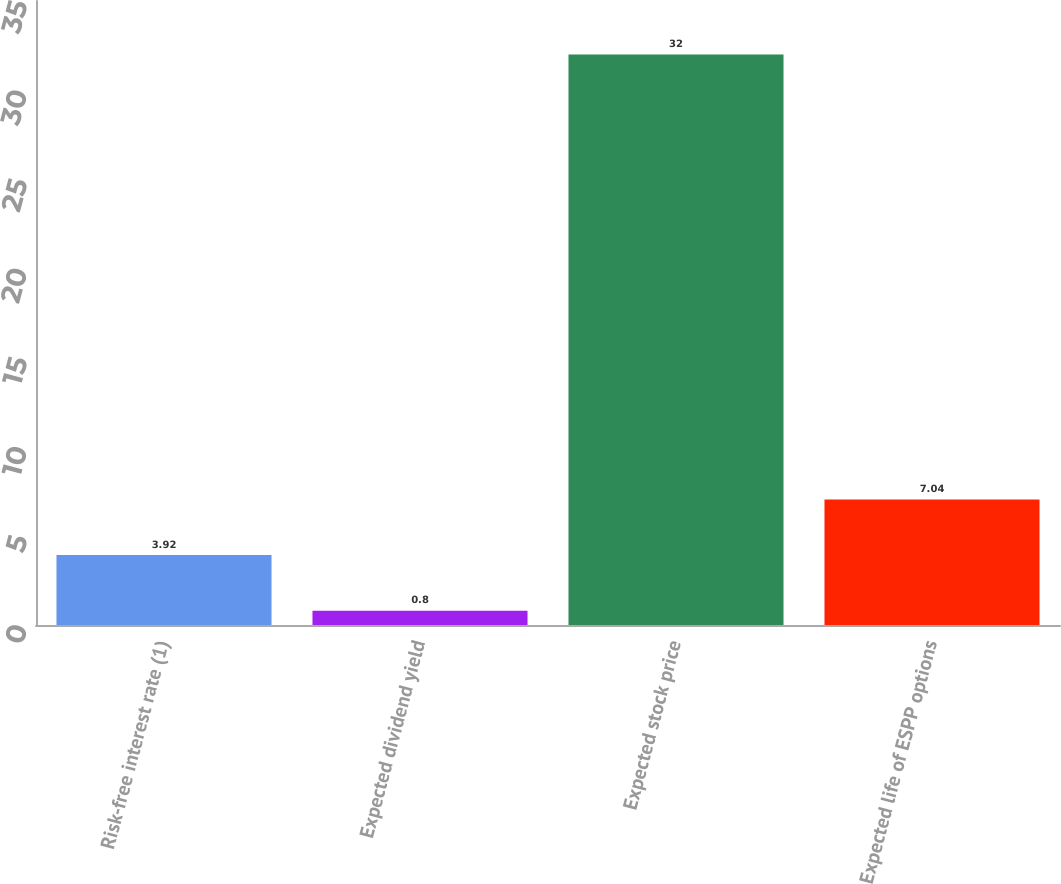Convert chart. <chart><loc_0><loc_0><loc_500><loc_500><bar_chart><fcel>Risk-free interest rate (1)<fcel>Expected dividend yield<fcel>Expected stock price<fcel>Expected life of ESPP options<nl><fcel>3.92<fcel>0.8<fcel>32<fcel>7.04<nl></chart> 